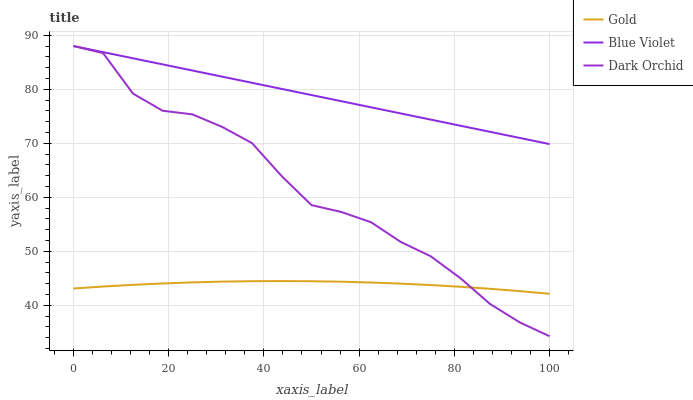Does Gold have the minimum area under the curve?
Answer yes or no. Yes. Does Blue Violet have the maximum area under the curve?
Answer yes or no. Yes. Does Blue Violet have the minimum area under the curve?
Answer yes or no. No. Does Gold have the maximum area under the curve?
Answer yes or no. No. Is Blue Violet the smoothest?
Answer yes or no. Yes. Is Dark Orchid the roughest?
Answer yes or no. Yes. Is Gold the smoothest?
Answer yes or no. No. Is Gold the roughest?
Answer yes or no. No. Does Dark Orchid have the lowest value?
Answer yes or no. Yes. Does Gold have the lowest value?
Answer yes or no. No. Does Blue Violet have the highest value?
Answer yes or no. Yes. Does Gold have the highest value?
Answer yes or no. No. Is Gold less than Blue Violet?
Answer yes or no. Yes. Is Blue Violet greater than Gold?
Answer yes or no. Yes. Does Blue Violet intersect Dark Orchid?
Answer yes or no. Yes. Is Blue Violet less than Dark Orchid?
Answer yes or no. No. Is Blue Violet greater than Dark Orchid?
Answer yes or no. No. Does Gold intersect Blue Violet?
Answer yes or no. No. 